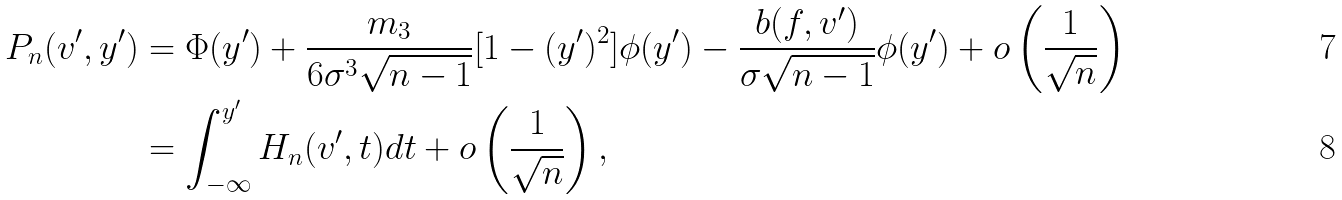Convert formula to latex. <formula><loc_0><loc_0><loc_500><loc_500>P _ { n } ( v ^ { \prime } , y ^ { \prime } ) & = \Phi ( y ^ { \prime } ) + \frac { m _ { 3 } } { 6 \sigma ^ { 3 } \sqrt { n - 1 } } [ 1 - ( y ^ { \prime } ) ^ { 2 } ] \phi ( y ^ { \prime } ) - \frac { b ( f , v ^ { \prime } ) } { \sigma \sqrt { n - 1 } } \phi ( y ^ { \prime } ) + o \left ( \frac { 1 } { \sqrt { n } } \right ) \\ & = \int _ { - \infty } ^ { y ^ { \prime } } H _ { n } ( v ^ { \prime } , t ) d t + o \left ( \frac { 1 } { \sqrt { n } } \right ) ,</formula> 